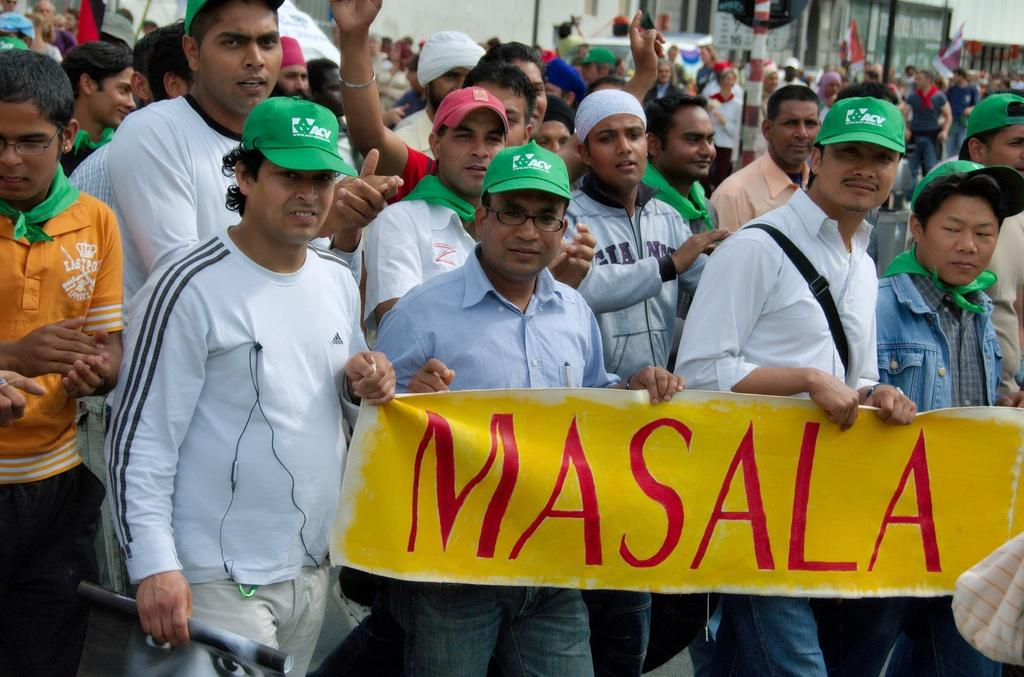How many people are in the image? There are people in the image, but the exact number is not specified. What are some of the people holding in the image? Some of the people are holding banners and flags in the image. What can be seen attached to a pole in the image? There is a pole with a board in the image. What is visible in the background of the image? There appears to be a building in the background of the image. Can you tell me the color of the mint that the grandfather is holding in the image? There is no mention of mint or a grandfather in the image, so we cannot answer this question. 